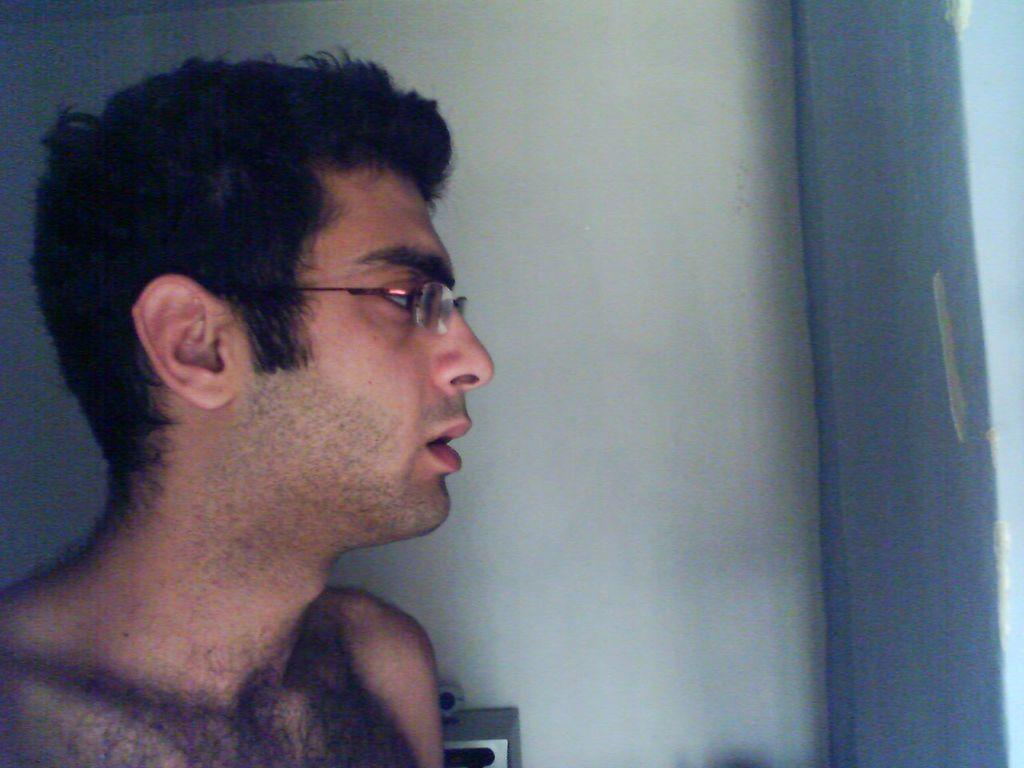Who is present in the image? There is a man in the image. What can be seen on the man's face? The man is wearing glasses. What is visible behind the man? There is a wall in the background of the image. Can you describe the object in the background? There is an object visible in the background of the image. What type of cloth is the man biting in the image? There is no cloth or biting action present in the image. 